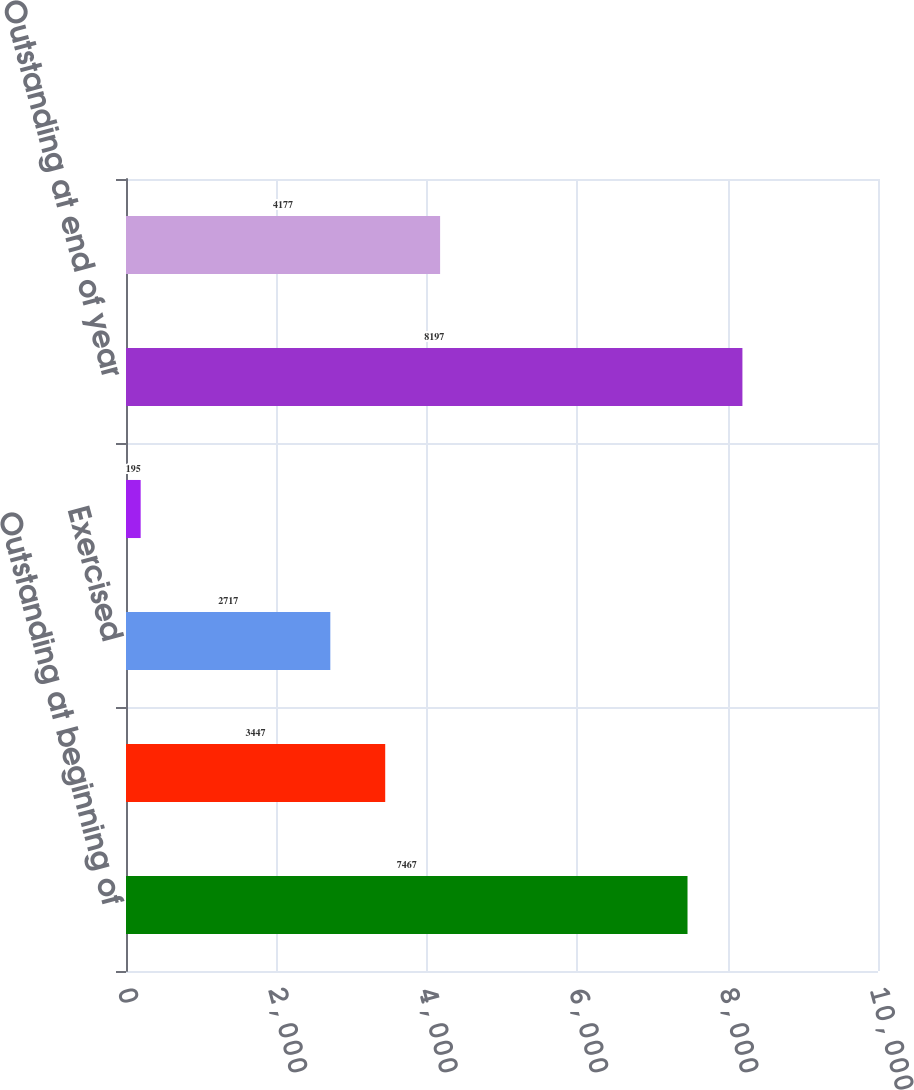<chart> <loc_0><loc_0><loc_500><loc_500><bar_chart><fcel>Outstanding at beginning of<fcel>Granted<fcel>Exercised<fcel>Forfeited<fcel>Outstanding at end of year<fcel>Exercisable at year-end<nl><fcel>7467<fcel>3447<fcel>2717<fcel>195<fcel>8197<fcel>4177<nl></chart> 